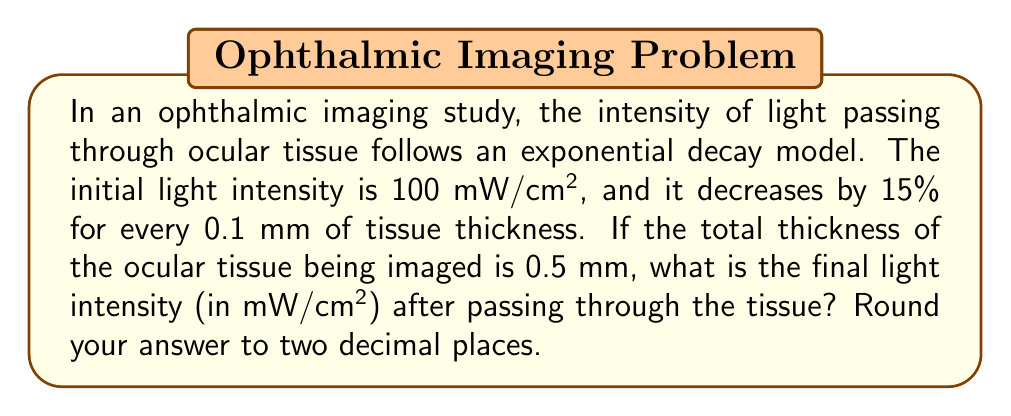What is the answer to this math problem? Let's approach this step-by-step:

1) First, we need to determine the decay factor for each 0.1 mm of tissue:
   The intensity decreases by 15%, so it remains at 85% of its previous value.
   Decay factor = 1 - 0.15 = 0.85

2) Now, we can set up our exponential decay function:
   $I(x) = I_0 \cdot (0.85)^{x/0.1}$
   Where:
   $I(x)$ is the intensity at depth $x$ (in mm)
   $I_0$ is the initial intensity (100 mW/cm²)
   $x$ is the depth (0.5 mm in this case)

3) Let's substitute our values:
   $I(0.5) = 100 \cdot (0.85)^{0.5/0.1}$

4) Simplify the exponent:
   $I(0.5) = 100 \cdot (0.85)^5$

5) Calculate:
   $I(0.5) = 100 \cdot 0.4437053462...$ 
   $I(0.5) = 44.37053462...$

6) Rounding to two decimal places:
   $I(0.5) \approx 44.37$ mW/cm²

Therefore, the final light intensity after passing through 0.5 mm of ocular tissue is approximately 44.37 mW/cm².
Answer: 44.37 mW/cm² 